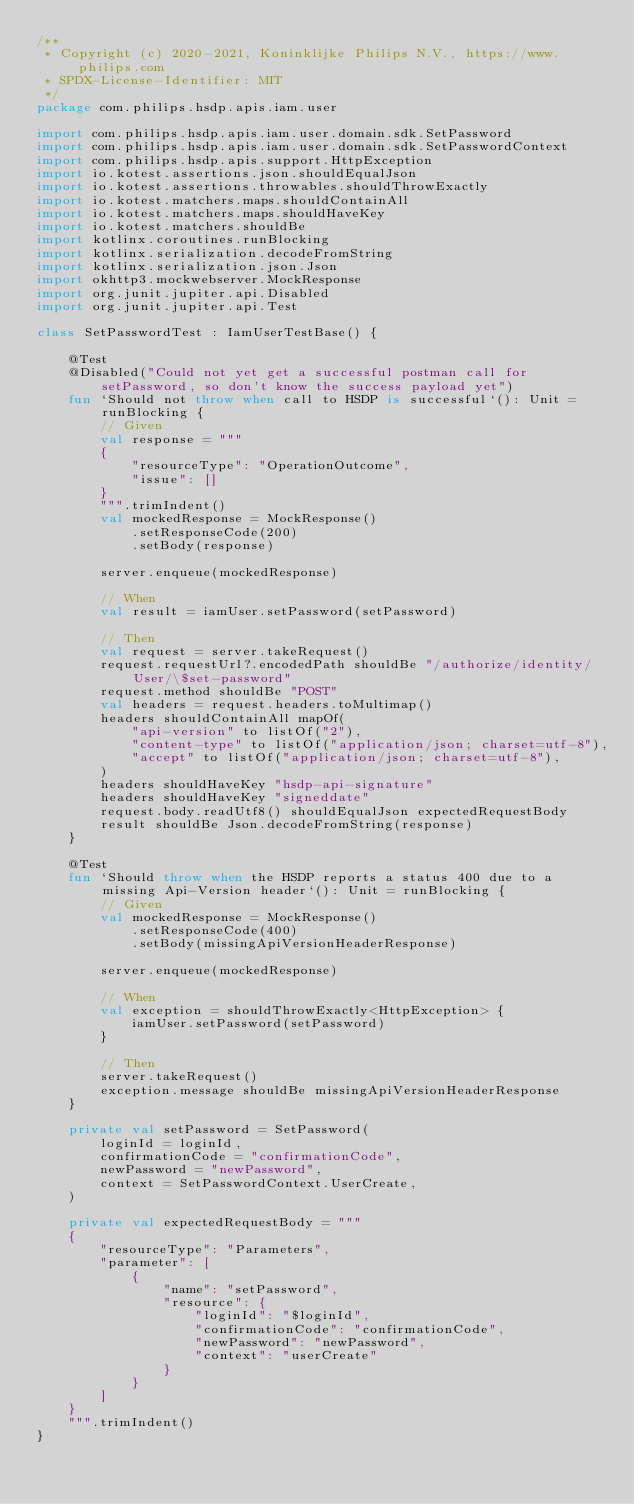Convert code to text. <code><loc_0><loc_0><loc_500><loc_500><_Kotlin_>/**
 * Copyright (c) 2020-2021, Koninklijke Philips N.V., https://www.philips.com
 * SPDX-License-Identifier: MIT
 */
package com.philips.hsdp.apis.iam.user

import com.philips.hsdp.apis.iam.user.domain.sdk.SetPassword
import com.philips.hsdp.apis.iam.user.domain.sdk.SetPasswordContext
import com.philips.hsdp.apis.support.HttpException
import io.kotest.assertions.json.shouldEqualJson
import io.kotest.assertions.throwables.shouldThrowExactly
import io.kotest.matchers.maps.shouldContainAll
import io.kotest.matchers.maps.shouldHaveKey
import io.kotest.matchers.shouldBe
import kotlinx.coroutines.runBlocking
import kotlinx.serialization.decodeFromString
import kotlinx.serialization.json.Json
import okhttp3.mockwebserver.MockResponse
import org.junit.jupiter.api.Disabled
import org.junit.jupiter.api.Test

class SetPasswordTest : IamUserTestBase() {

    @Test
    @Disabled("Could not yet get a successful postman call for setPassword, so don't know the success payload yet")
    fun `Should not throw when call to HSDP is successful`(): Unit = runBlocking {
        // Given
        val response = """
        {
            "resourceType": "OperationOutcome",
            "issue": []
        }
        """.trimIndent()
        val mockedResponse = MockResponse()
            .setResponseCode(200)
            .setBody(response)

        server.enqueue(mockedResponse)

        // When
        val result = iamUser.setPassword(setPassword)

        // Then
        val request = server.takeRequest()
        request.requestUrl?.encodedPath shouldBe "/authorize/identity/User/\$set-password"
        request.method shouldBe "POST"
        val headers = request.headers.toMultimap()
        headers shouldContainAll mapOf(
            "api-version" to listOf("2"),
            "content-type" to listOf("application/json; charset=utf-8"),
            "accept" to listOf("application/json; charset=utf-8"),
        )
        headers shouldHaveKey "hsdp-api-signature"
        headers shouldHaveKey "signeddate"
        request.body.readUtf8() shouldEqualJson expectedRequestBody
        result shouldBe Json.decodeFromString(response)
    }

    @Test
    fun `Should throw when the HSDP reports a status 400 due to a missing Api-Version header`(): Unit = runBlocking {
        // Given
        val mockedResponse = MockResponse()
            .setResponseCode(400)
            .setBody(missingApiVersionHeaderResponse)

        server.enqueue(mockedResponse)

        // When
        val exception = shouldThrowExactly<HttpException> {
            iamUser.setPassword(setPassword)
        }

        // Then
        server.takeRequest()
        exception.message shouldBe missingApiVersionHeaderResponse
    }

    private val setPassword = SetPassword(
        loginId = loginId,
        confirmationCode = "confirmationCode",
        newPassword = "newPassword",
        context = SetPasswordContext.UserCreate,
    )

    private val expectedRequestBody = """
    {
        "resourceType": "Parameters",
        "parameter": [
            {
                "name": "setPassword",
                "resource": {
                    "loginId": "$loginId",
                    "confirmationCode": "confirmationCode",
                    "newPassword": "newPassword",
                    "context": "userCreate"
                }
            }
        ]
    }
    """.trimIndent()
}</code> 